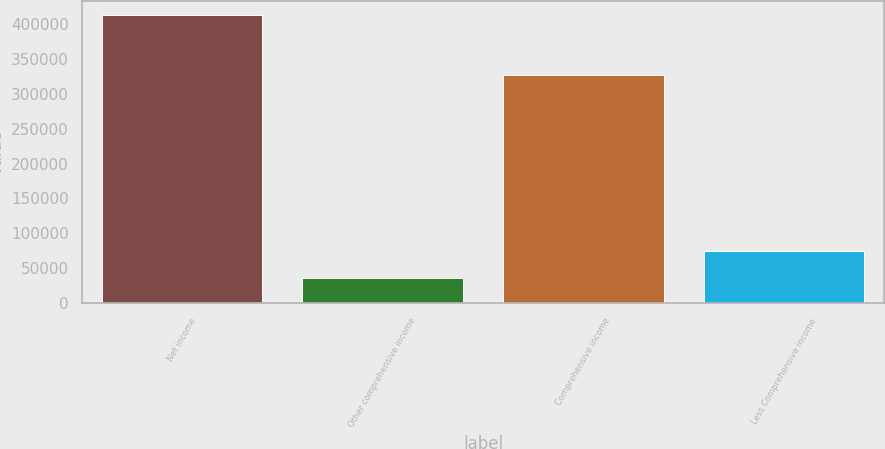Convert chart. <chart><loc_0><loc_0><loc_500><loc_500><bar_chart><fcel>Net income<fcel>Other comprehensive income<fcel>Comprehensive income<fcel>Less Comprehensive income<nl><fcel>412251<fcel>36671<fcel>326073<fcel>74148.4<nl></chart> 